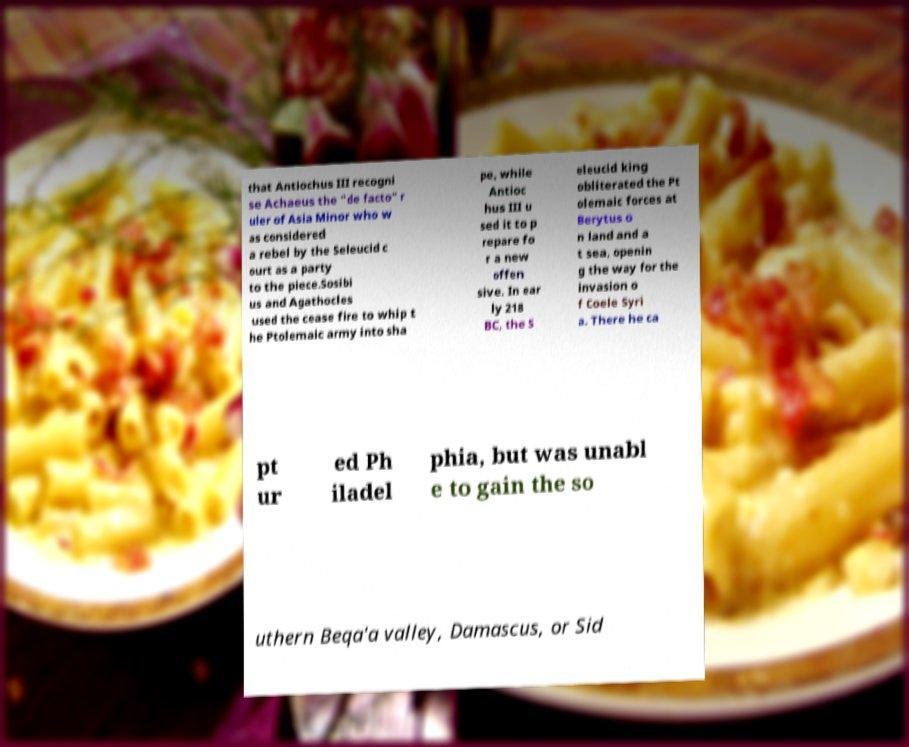What messages or text are displayed in this image? I need them in a readable, typed format. that Antiochus III recogni se Achaeus the "de facto" r uler of Asia Minor who w as considered a rebel by the Seleucid c ourt as a party to the piece.Sosibi us and Agathocles used the cease fire to whip t he Ptolemaic army into sha pe, while Antioc hus III u sed it to p repare fo r a new offen sive. In ear ly 218 BC, the S eleucid king obliterated the Pt olemaic forces at Berytus o n land and a t sea, openin g the way for the invasion o f Coele Syri a. There he ca pt ur ed Ph iladel phia, but was unabl e to gain the so uthern Beqa'a valley, Damascus, or Sid 